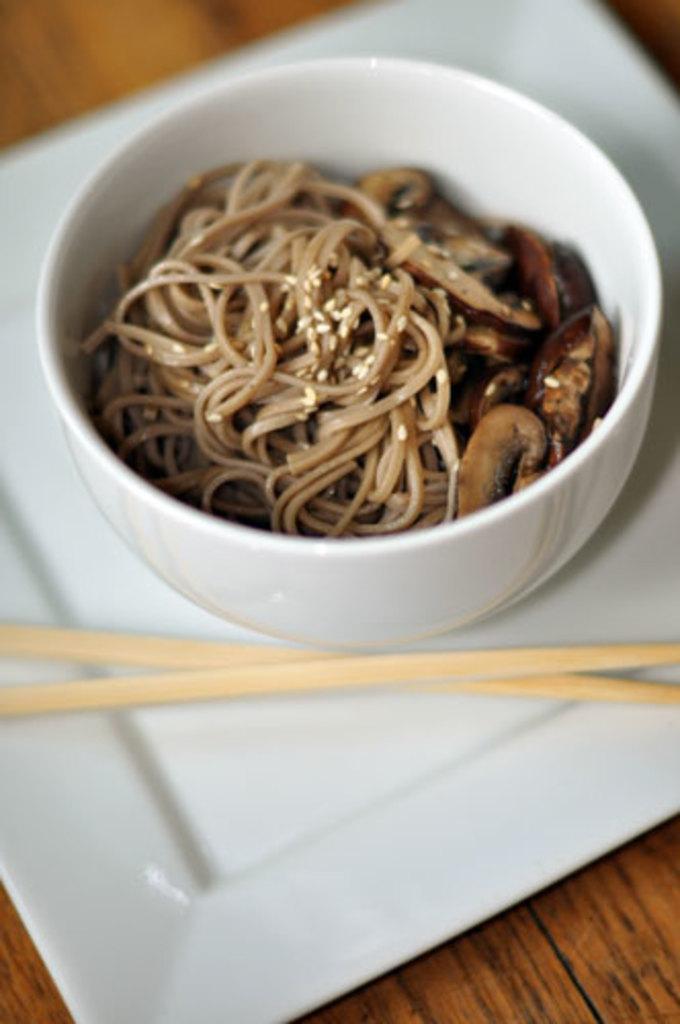In one or two sentences, can you explain what this image depicts? On the table there is a white color plate. On the plate there are two chopsticks and a bowl. Inside the bowl there is a food item. 